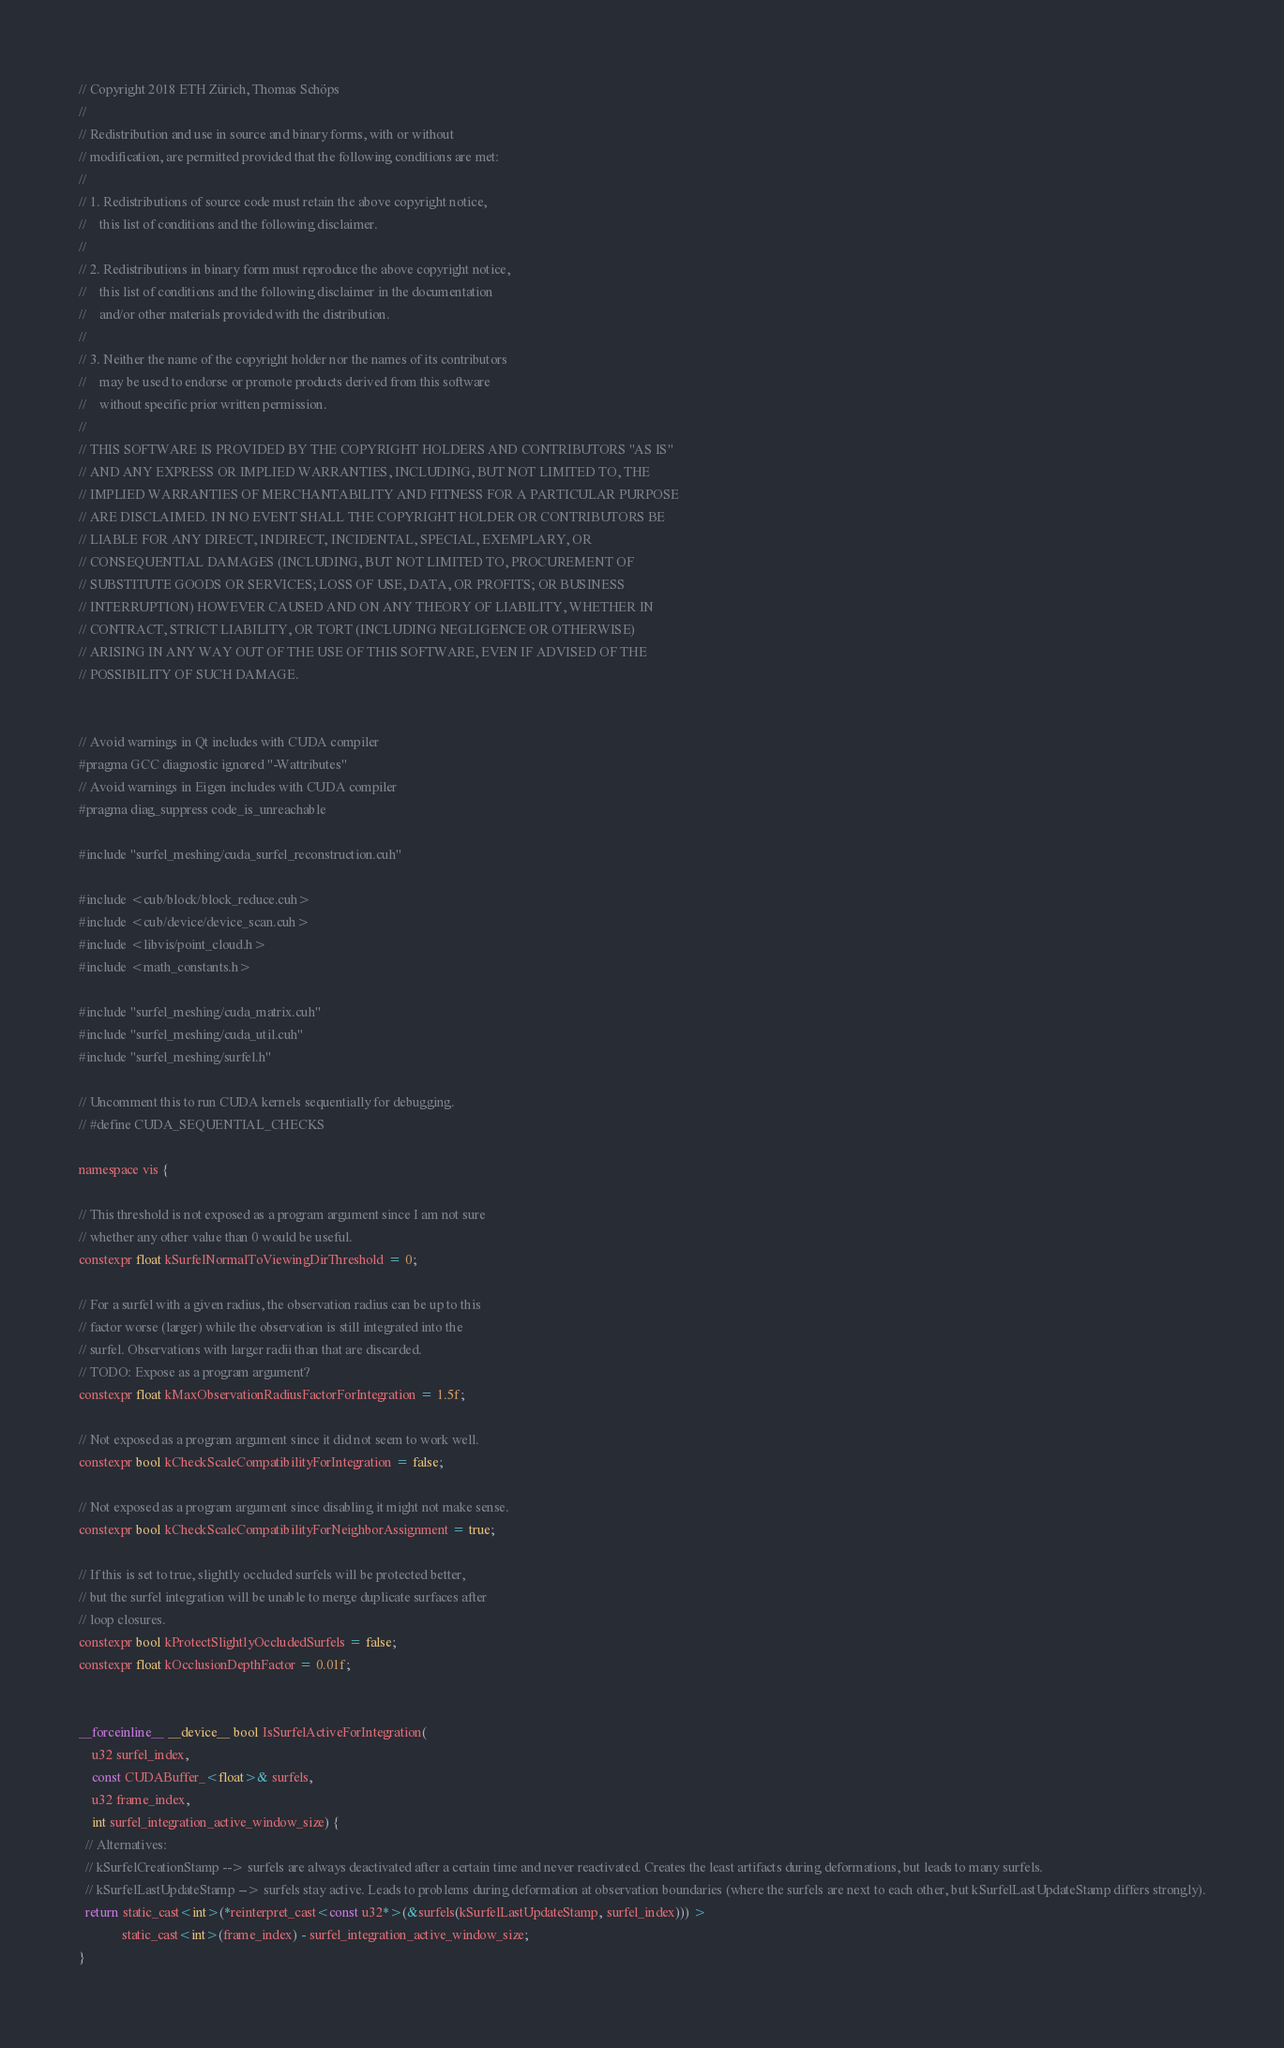<code> <loc_0><loc_0><loc_500><loc_500><_Cuda_>// Copyright 2018 ETH Zürich, Thomas Schöps
//
// Redistribution and use in source and binary forms, with or without
// modification, are permitted provided that the following conditions are met:
//
// 1. Redistributions of source code must retain the above copyright notice,
//    this list of conditions and the following disclaimer.
//
// 2. Redistributions in binary form must reproduce the above copyright notice,
//    this list of conditions and the following disclaimer in the documentation
//    and/or other materials provided with the distribution.
//
// 3. Neither the name of the copyright holder nor the names of its contributors
//    may be used to endorse or promote products derived from this software
//    without specific prior written permission.
//
// THIS SOFTWARE IS PROVIDED BY THE COPYRIGHT HOLDERS AND CONTRIBUTORS "AS IS"
// AND ANY EXPRESS OR IMPLIED WARRANTIES, INCLUDING, BUT NOT LIMITED TO, THE
// IMPLIED WARRANTIES OF MERCHANTABILITY AND FITNESS FOR A PARTICULAR PURPOSE
// ARE DISCLAIMED. IN NO EVENT SHALL THE COPYRIGHT HOLDER OR CONTRIBUTORS BE
// LIABLE FOR ANY DIRECT, INDIRECT, INCIDENTAL, SPECIAL, EXEMPLARY, OR
// CONSEQUENTIAL DAMAGES (INCLUDING, BUT NOT LIMITED TO, PROCUREMENT OF
// SUBSTITUTE GOODS OR SERVICES; LOSS OF USE, DATA, OR PROFITS; OR BUSINESS
// INTERRUPTION) HOWEVER CAUSED AND ON ANY THEORY OF LIABILITY, WHETHER IN
// CONTRACT, STRICT LIABILITY, OR TORT (INCLUDING NEGLIGENCE OR OTHERWISE)
// ARISING IN ANY WAY OUT OF THE USE OF THIS SOFTWARE, EVEN IF ADVISED OF THE
// POSSIBILITY OF SUCH DAMAGE.


// Avoid warnings in Qt includes with CUDA compiler
#pragma GCC diagnostic ignored "-Wattributes"
// Avoid warnings in Eigen includes with CUDA compiler
#pragma diag_suppress code_is_unreachable

#include "surfel_meshing/cuda_surfel_reconstruction.cuh"

#include <cub/block/block_reduce.cuh>
#include <cub/device/device_scan.cuh>
#include <libvis/point_cloud.h>
#include <math_constants.h>

#include "surfel_meshing/cuda_matrix.cuh"
#include "surfel_meshing/cuda_util.cuh"
#include "surfel_meshing/surfel.h"

// Uncomment this to run CUDA kernels sequentially for debugging.
// #define CUDA_SEQUENTIAL_CHECKS

namespace vis {

// This threshold is not exposed as a program argument since I am not sure
// whether any other value than 0 would be useful.
constexpr float kSurfelNormalToViewingDirThreshold = 0;

// For a surfel with a given radius, the observation radius can be up to this
// factor worse (larger) while the observation is still integrated into the
// surfel. Observations with larger radii than that are discarded.
// TODO: Expose as a program argument?
constexpr float kMaxObservationRadiusFactorForIntegration = 1.5f;

// Not exposed as a program argument since it did not seem to work well.
constexpr bool kCheckScaleCompatibilityForIntegration = false;

// Not exposed as a program argument since disabling it might not make sense.
constexpr bool kCheckScaleCompatibilityForNeighborAssignment = true;

// If this is set to true, slightly occluded surfels will be protected better,
// but the surfel integration will be unable to merge duplicate surfaces after
// loop closures.
constexpr bool kProtectSlightlyOccludedSurfels = false;
constexpr float kOcclusionDepthFactor = 0.01f;


__forceinline__ __device__ bool IsSurfelActiveForIntegration(
    u32 surfel_index,
    const CUDABuffer_<float>& surfels,
    u32 frame_index,
    int surfel_integration_active_window_size) {
  // Alternatives:
  // kSurfelCreationStamp --> surfels are always deactivated after a certain time and never reactivated. Creates the least artifacts during deformations, but leads to many surfels.
  // kSurfelLastUpdateStamp --> surfels stay active. Leads to problems during deformation at observation boundaries (where the surfels are next to each other, but kSurfelLastUpdateStamp differs strongly).
  return static_cast<int>(*reinterpret_cast<const u32*>(&surfels(kSurfelLastUpdateStamp, surfel_index))) >
             static_cast<int>(frame_index) - surfel_integration_active_window_size;
}

</code> 